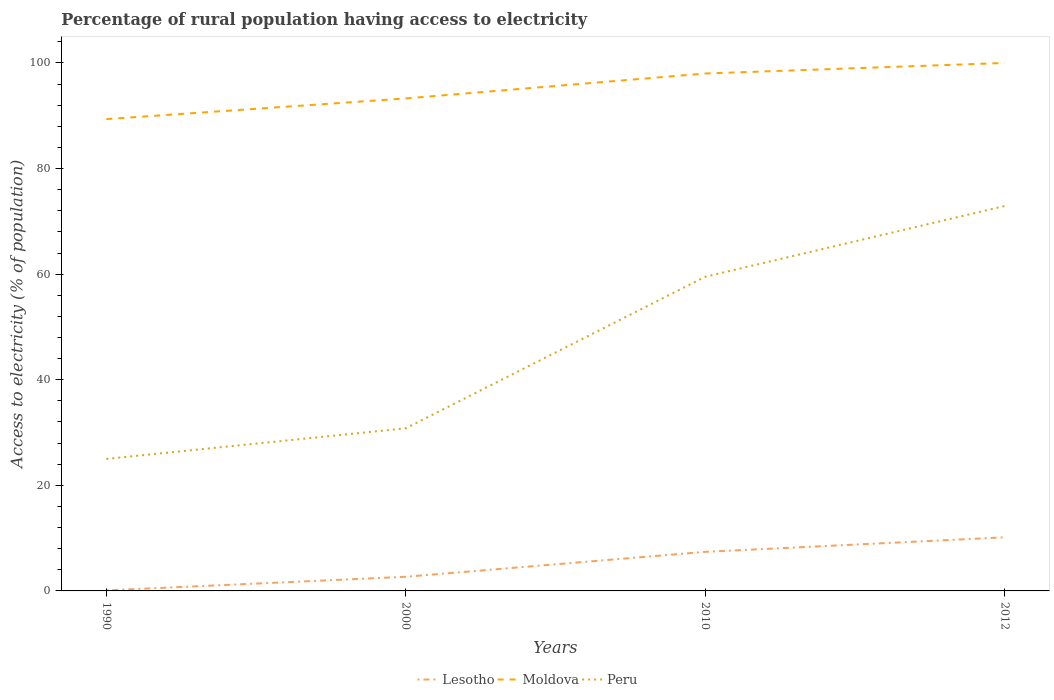How many different coloured lines are there?
Your answer should be very brief. 3. Does the line corresponding to Peru intersect with the line corresponding to Lesotho?
Offer a terse response. No. Is the number of lines equal to the number of legend labels?
Provide a succinct answer. Yes. What is the total percentage of rural population having access to electricity in Peru in the graph?
Make the answer very short. -47.9. What is the difference between the highest and the second highest percentage of rural population having access to electricity in Lesotho?
Provide a succinct answer. 10.05. Are the values on the major ticks of Y-axis written in scientific E-notation?
Give a very brief answer. No. Does the graph contain any zero values?
Offer a terse response. No. Where does the legend appear in the graph?
Keep it short and to the point. Bottom center. How many legend labels are there?
Your response must be concise. 3. What is the title of the graph?
Offer a very short reply. Percentage of rural population having access to electricity. Does "Hong Kong" appear as one of the legend labels in the graph?
Keep it short and to the point. No. What is the label or title of the X-axis?
Provide a succinct answer. Years. What is the label or title of the Y-axis?
Offer a terse response. Access to electricity (% of population). What is the Access to electricity (% of population) of Moldova in 1990?
Your response must be concise. 89.36. What is the Access to electricity (% of population) of Lesotho in 2000?
Offer a very short reply. 2.68. What is the Access to electricity (% of population) in Moldova in 2000?
Offer a terse response. 93.28. What is the Access to electricity (% of population) in Peru in 2000?
Provide a short and direct response. 30.8. What is the Access to electricity (% of population) in Lesotho in 2010?
Make the answer very short. 7.4. What is the Access to electricity (% of population) of Peru in 2010?
Make the answer very short. 59.5. What is the Access to electricity (% of population) of Lesotho in 2012?
Give a very brief answer. 10.15. What is the Access to electricity (% of population) of Moldova in 2012?
Make the answer very short. 100. What is the Access to electricity (% of population) of Peru in 2012?
Your answer should be very brief. 72.9. Across all years, what is the maximum Access to electricity (% of population) in Lesotho?
Give a very brief answer. 10.15. Across all years, what is the maximum Access to electricity (% of population) of Peru?
Offer a terse response. 72.9. Across all years, what is the minimum Access to electricity (% of population) in Lesotho?
Your answer should be very brief. 0.1. Across all years, what is the minimum Access to electricity (% of population) in Moldova?
Provide a succinct answer. 89.36. Across all years, what is the minimum Access to electricity (% of population) of Peru?
Keep it short and to the point. 25. What is the total Access to electricity (% of population) of Lesotho in the graph?
Your answer should be compact. 20.34. What is the total Access to electricity (% of population) in Moldova in the graph?
Give a very brief answer. 380.64. What is the total Access to electricity (% of population) of Peru in the graph?
Ensure brevity in your answer.  188.2. What is the difference between the Access to electricity (% of population) in Lesotho in 1990 and that in 2000?
Provide a succinct answer. -2.58. What is the difference between the Access to electricity (% of population) of Moldova in 1990 and that in 2000?
Your response must be concise. -3.92. What is the difference between the Access to electricity (% of population) in Peru in 1990 and that in 2000?
Ensure brevity in your answer.  -5.8. What is the difference between the Access to electricity (% of population) in Lesotho in 1990 and that in 2010?
Your response must be concise. -7.3. What is the difference between the Access to electricity (% of population) in Moldova in 1990 and that in 2010?
Ensure brevity in your answer.  -8.64. What is the difference between the Access to electricity (% of population) of Peru in 1990 and that in 2010?
Keep it short and to the point. -34.5. What is the difference between the Access to electricity (% of population) of Lesotho in 1990 and that in 2012?
Offer a very short reply. -10.05. What is the difference between the Access to electricity (% of population) of Moldova in 1990 and that in 2012?
Keep it short and to the point. -10.64. What is the difference between the Access to electricity (% of population) in Peru in 1990 and that in 2012?
Provide a succinct answer. -47.9. What is the difference between the Access to electricity (% of population) of Lesotho in 2000 and that in 2010?
Your answer should be very brief. -4.72. What is the difference between the Access to electricity (% of population) in Moldova in 2000 and that in 2010?
Your answer should be compact. -4.72. What is the difference between the Access to electricity (% of population) of Peru in 2000 and that in 2010?
Your response must be concise. -28.7. What is the difference between the Access to electricity (% of population) in Lesotho in 2000 and that in 2012?
Your answer should be very brief. -7.47. What is the difference between the Access to electricity (% of population) in Moldova in 2000 and that in 2012?
Offer a very short reply. -6.72. What is the difference between the Access to electricity (% of population) of Peru in 2000 and that in 2012?
Your response must be concise. -42.1. What is the difference between the Access to electricity (% of population) of Lesotho in 2010 and that in 2012?
Your answer should be very brief. -2.75. What is the difference between the Access to electricity (% of population) of Peru in 2010 and that in 2012?
Make the answer very short. -13.4. What is the difference between the Access to electricity (% of population) of Lesotho in 1990 and the Access to electricity (% of population) of Moldova in 2000?
Your answer should be compact. -93.18. What is the difference between the Access to electricity (% of population) of Lesotho in 1990 and the Access to electricity (% of population) of Peru in 2000?
Keep it short and to the point. -30.7. What is the difference between the Access to electricity (% of population) of Moldova in 1990 and the Access to electricity (% of population) of Peru in 2000?
Your response must be concise. 58.56. What is the difference between the Access to electricity (% of population) of Lesotho in 1990 and the Access to electricity (% of population) of Moldova in 2010?
Your answer should be compact. -97.9. What is the difference between the Access to electricity (% of population) in Lesotho in 1990 and the Access to electricity (% of population) in Peru in 2010?
Your answer should be very brief. -59.4. What is the difference between the Access to electricity (% of population) of Moldova in 1990 and the Access to electricity (% of population) of Peru in 2010?
Provide a succinct answer. 29.86. What is the difference between the Access to electricity (% of population) of Lesotho in 1990 and the Access to electricity (% of population) of Moldova in 2012?
Offer a very short reply. -99.9. What is the difference between the Access to electricity (% of population) of Lesotho in 1990 and the Access to electricity (% of population) of Peru in 2012?
Your response must be concise. -72.8. What is the difference between the Access to electricity (% of population) of Moldova in 1990 and the Access to electricity (% of population) of Peru in 2012?
Provide a succinct answer. 16.46. What is the difference between the Access to electricity (% of population) of Lesotho in 2000 and the Access to electricity (% of population) of Moldova in 2010?
Provide a succinct answer. -95.32. What is the difference between the Access to electricity (% of population) of Lesotho in 2000 and the Access to electricity (% of population) of Peru in 2010?
Give a very brief answer. -56.82. What is the difference between the Access to electricity (% of population) in Moldova in 2000 and the Access to electricity (% of population) in Peru in 2010?
Provide a short and direct response. 33.78. What is the difference between the Access to electricity (% of population) of Lesotho in 2000 and the Access to electricity (% of population) of Moldova in 2012?
Your answer should be very brief. -97.32. What is the difference between the Access to electricity (% of population) in Lesotho in 2000 and the Access to electricity (% of population) in Peru in 2012?
Make the answer very short. -70.22. What is the difference between the Access to electricity (% of population) of Moldova in 2000 and the Access to electricity (% of population) of Peru in 2012?
Provide a succinct answer. 20.38. What is the difference between the Access to electricity (% of population) in Lesotho in 2010 and the Access to electricity (% of population) in Moldova in 2012?
Provide a succinct answer. -92.6. What is the difference between the Access to electricity (% of population) of Lesotho in 2010 and the Access to electricity (% of population) of Peru in 2012?
Give a very brief answer. -65.5. What is the difference between the Access to electricity (% of population) of Moldova in 2010 and the Access to electricity (% of population) of Peru in 2012?
Ensure brevity in your answer.  25.1. What is the average Access to electricity (% of population) of Lesotho per year?
Give a very brief answer. 5.08. What is the average Access to electricity (% of population) of Moldova per year?
Your response must be concise. 95.16. What is the average Access to electricity (% of population) in Peru per year?
Provide a succinct answer. 47.05. In the year 1990, what is the difference between the Access to electricity (% of population) in Lesotho and Access to electricity (% of population) in Moldova?
Provide a short and direct response. -89.26. In the year 1990, what is the difference between the Access to electricity (% of population) in Lesotho and Access to electricity (% of population) in Peru?
Offer a terse response. -24.9. In the year 1990, what is the difference between the Access to electricity (% of population) of Moldova and Access to electricity (% of population) of Peru?
Offer a terse response. 64.36. In the year 2000, what is the difference between the Access to electricity (% of population) of Lesotho and Access to electricity (% of population) of Moldova?
Offer a terse response. -90.6. In the year 2000, what is the difference between the Access to electricity (% of population) of Lesotho and Access to electricity (% of population) of Peru?
Keep it short and to the point. -28.12. In the year 2000, what is the difference between the Access to electricity (% of population) of Moldova and Access to electricity (% of population) of Peru?
Your answer should be very brief. 62.48. In the year 2010, what is the difference between the Access to electricity (% of population) of Lesotho and Access to electricity (% of population) of Moldova?
Offer a very short reply. -90.6. In the year 2010, what is the difference between the Access to electricity (% of population) in Lesotho and Access to electricity (% of population) in Peru?
Ensure brevity in your answer.  -52.1. In the year 2010, what is the difference between the Access to electricity (% of population) in Moldova and Access to electricity (% of population) in Peru?
Your answer should be very brief. 38.5. In the year 2012, what is the difference between the Access to electricity (% of population) of Lesotho and Access to electricity (% of population) of Moldova?
Give a very brief answer. -89.85. In the year 2012, what is the difference between the Access to electricity (% of population) in Lesotho and Access to electricity (% of population) in Peru?
Your answer should be very brief. -62.75. In the year 2012, what is the difference between the Access to electricity (% of population) of Moldova and Access to electricity (% of population) of Peru?
Ensure brevity in your answer.  27.1. What is the ratio of the Access to electricity (% of population) of Lesotho in 1990 to that in 2000?
Offer a very short reply. 0.04. What is the ratio of the Access to electricity (% of population) of Moldova in 1990 to that in 2000?
Provide a succinct answer. 0.96. What is the ratio of the Access to electricity (% of population) of Peru in 1990 to that in 2000?
Provide a short and direct response. 0.81. What is the ratio of the Access to electricity (% of population) in Lesotho in 1990 to that in 2010?
Your response must be concise. 0.01. What is the ratio of the Access to electricity (% of population) of Moldova in 1990 to that in 2010?
Your answer should be compact. 0.91. What is the ratio of the Access to electricity (% of population) of Peru in 1990 to that in 2010?
Your answer should be compact. 0.42. What is the ratio of the Access to electricity (% of population) of Lesotho in 1990 to that in 2012?
Make the answer very short. 0.01. What is the ratio of the Access to electricity (% of population) of Moldova in 1990 to that in 2012?
Provide a short and direct response. 0.89. What is the ratio of the Access to electricity (% of population) in Peru in 1990 to that in 2012?
Make the answer very short. 0.34. What is the ratio of the Access to electricity (% of population) in Lesotho in 2000 to that in 2010?
Offer a terse response. 0.36. What is the ratio of the Access to electricity (% of population) of Moldova in 2000 to that in 2010?
Offer a terse response. 0.95. What is the ratio of the Access to electricity (% of population) in Peru in 2000 to that in 2010?
Your answer should be very brief. 0.52. What is the ratio of the Access to electricity (% of population) in Lesotho in 2000 to that in 2012?
Ensure brevity in your answer.  0.26. What is the ratio of the Access to electricity (% of population) in Moldova in 2000 to that in 2012?
Keep it short and to the point. 0.93. What is the ratio of the Access to electricity (% of population) in Peru in 2000 to that in 2012?
Give a very brief answer. 0.42. What is the ratio of the Access to electricity (% of population) in Lesotho in 2010 to that in 2012?
Provide a short and direct response. 0.73. What is the ratio of the Access to electricity (% of population) of Peru in 2010 to that in 2012?
Provide a short and direct response. 0.82. What is the difference between the highest and the second highest Access to electricity (% of population) in Lesotho?
Make the answer very short. 2.75. What is the difference between the highest and the lowest Access to electricity (% of population) of Lesotho?
Give a very brief answer. 10.05. What is the difference between the highest and the lowest Access to electricity (% of population) in Moldova?
Offer a very short reply. 10.64. What is the difference between the highest and the lowest Access to electricity (% of population) of Peru?
Provide a succinct answer. 47.9. 